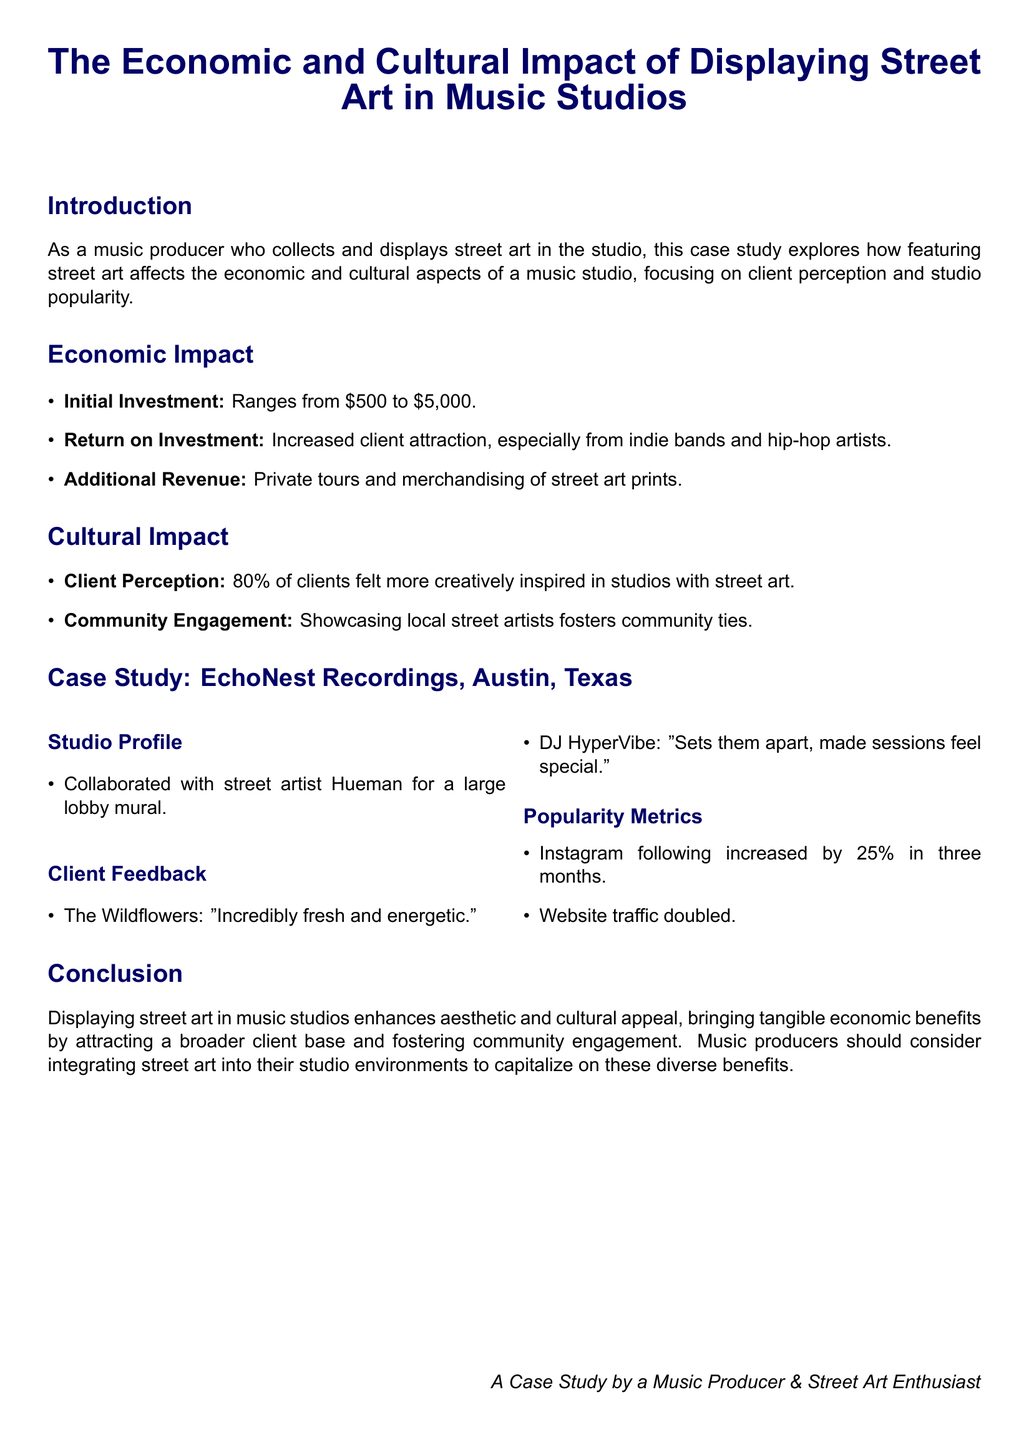What is the range of initial investment for displaying street art? The initial investment ranges from $500 to $5,000 as stated in the document.
Answer: $500 to $5,000 What percentage of clients felt more creatively inspired in studios with street art? The document states that 80% of clients felt more creatively inspired in studios with street art.
Answer: 80% What was the increase in Instagram following for EchoNest Recordings in three months? The document notes that the Instagram following increased by 25% in three months.
Answer: 25% Who collaborated with EchoNest Recordings for a mural? The document specifies that street artist Hueman collaborated with EchoNest Recordings for a large lobby mural.
Answer: Hueman What effect did showcasing local street artists have on community ties? The document mentions that showcasing local street artists fosters community ties, indicating a positive cultural impact.
Answer: Fosters community ties What was the impact on website traffic for EchoNest Recordings? The website traffic for EchoNest Recordings doubled according to the document.
Answer: Doubled What did DJ HyperVibe say about the effect of street art on recording sessions? DJ HyperVibe remarked that it sets them apart, making sessions feel special as mentioned in the feedback section.
Answer: Made sessions feel special What is one source of additional revenue mentioned in the economic impact section? The document lists private tours as one source of additional revenue generated by the studio.
Answer: Private tours 